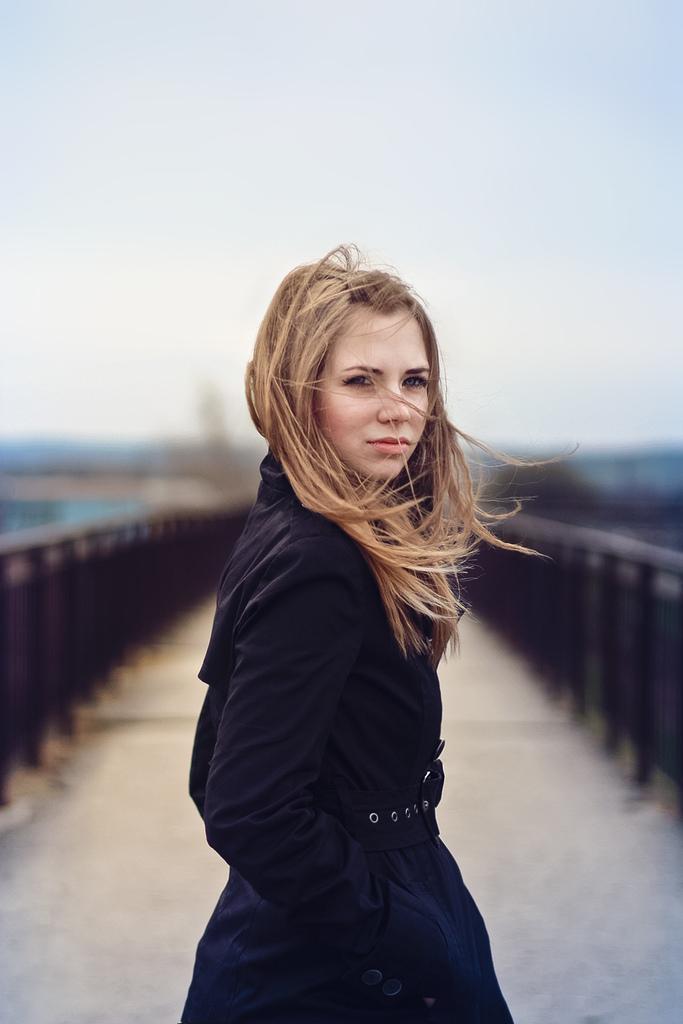How would you summarize this image in a sentence or two? In the center of the image we can see women standing on the floor. In the background we can see bridge, sky. 